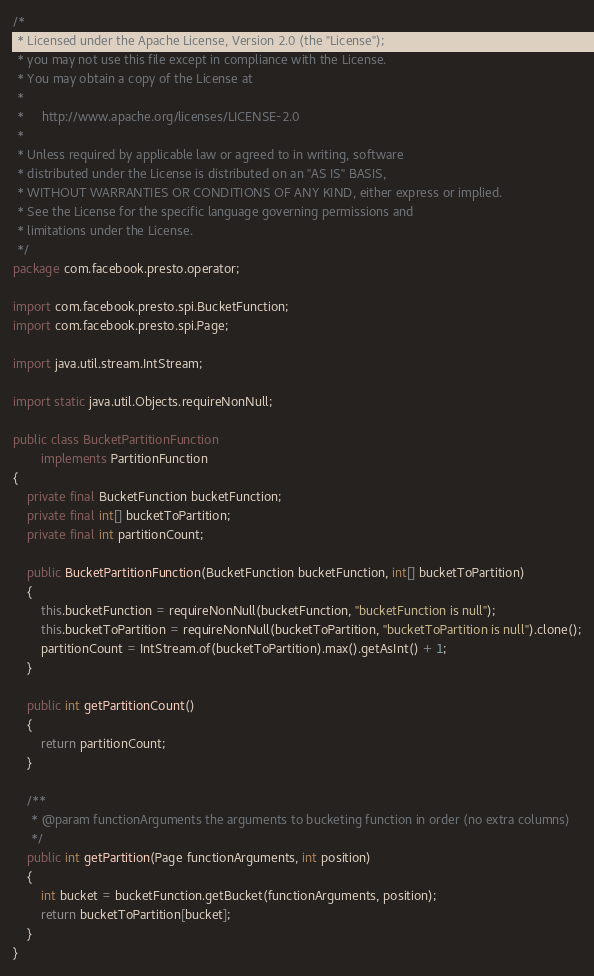Convert code to text. <code><loc_0><loc_0><loc_500><loc_500><_Java_>/*
 * Licensed under the Apache License, Version 2.0 (the "License");
 * you may not use this file except in compliance with the License.
 * You may obtain a copy of the License at
 *
 *     http://www.apache.org/licenses/LICENSE-2.0
 *
 * Unless required by applicable law or agreed to in writing, software
 * distributed under the License is distributed on an "AS IS" BASIS,
 * WITHOUT WARRANTIES OR CONDITIONS OF ANY KIND, either express or implied.
 * See the License for the specific language governing permissions and
 * limitations under the License.
 */
package com.facebook.presto.operator;

import com.facebook.presto.spi.BucketFunction;
import com.facebook.presto.spi.Page;

import java.util.stream.IntStream;

import static java.util.Objects.requireNonNull;

public class BucketPartitionFunction
        implements PartitionFunction
{
    private final BucketFunction bucketFunction;
    private final int[] bucketToPartition;
    private final int partitionCount;

    public BucketPartitionFunction(BucketFunction bucketFunction, int[] bucketToPartition)
    {
        this.bucketFunction = requireNonNull(bucketFunction, "bucketFunction is null");
        this.bucketToPartition = requireNonNull(bucketToPartition, "bucketToPartition is null").clone();
        partitionCount = IntStream.of(bucketToPartition).max().getAsInt() + 1;
    }

    public int getPartitionCount()
    {
        return partitionCount;
    }

    /**
     * @param functionArguments the arguments to bucketing function in order (no extra columns)
     */
    public int getPartition(Page functionArguments, int position)
    {
        int bucket = bucketFunction.getBucket(functionArguments, position);
        return bucketToPartition[bucket];
    }
}
</code> 